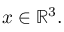<formula> <loc_0><loc_0><loc_500><loc_500>x \in \mathbb { R } ^ { 3 } .</formula> 